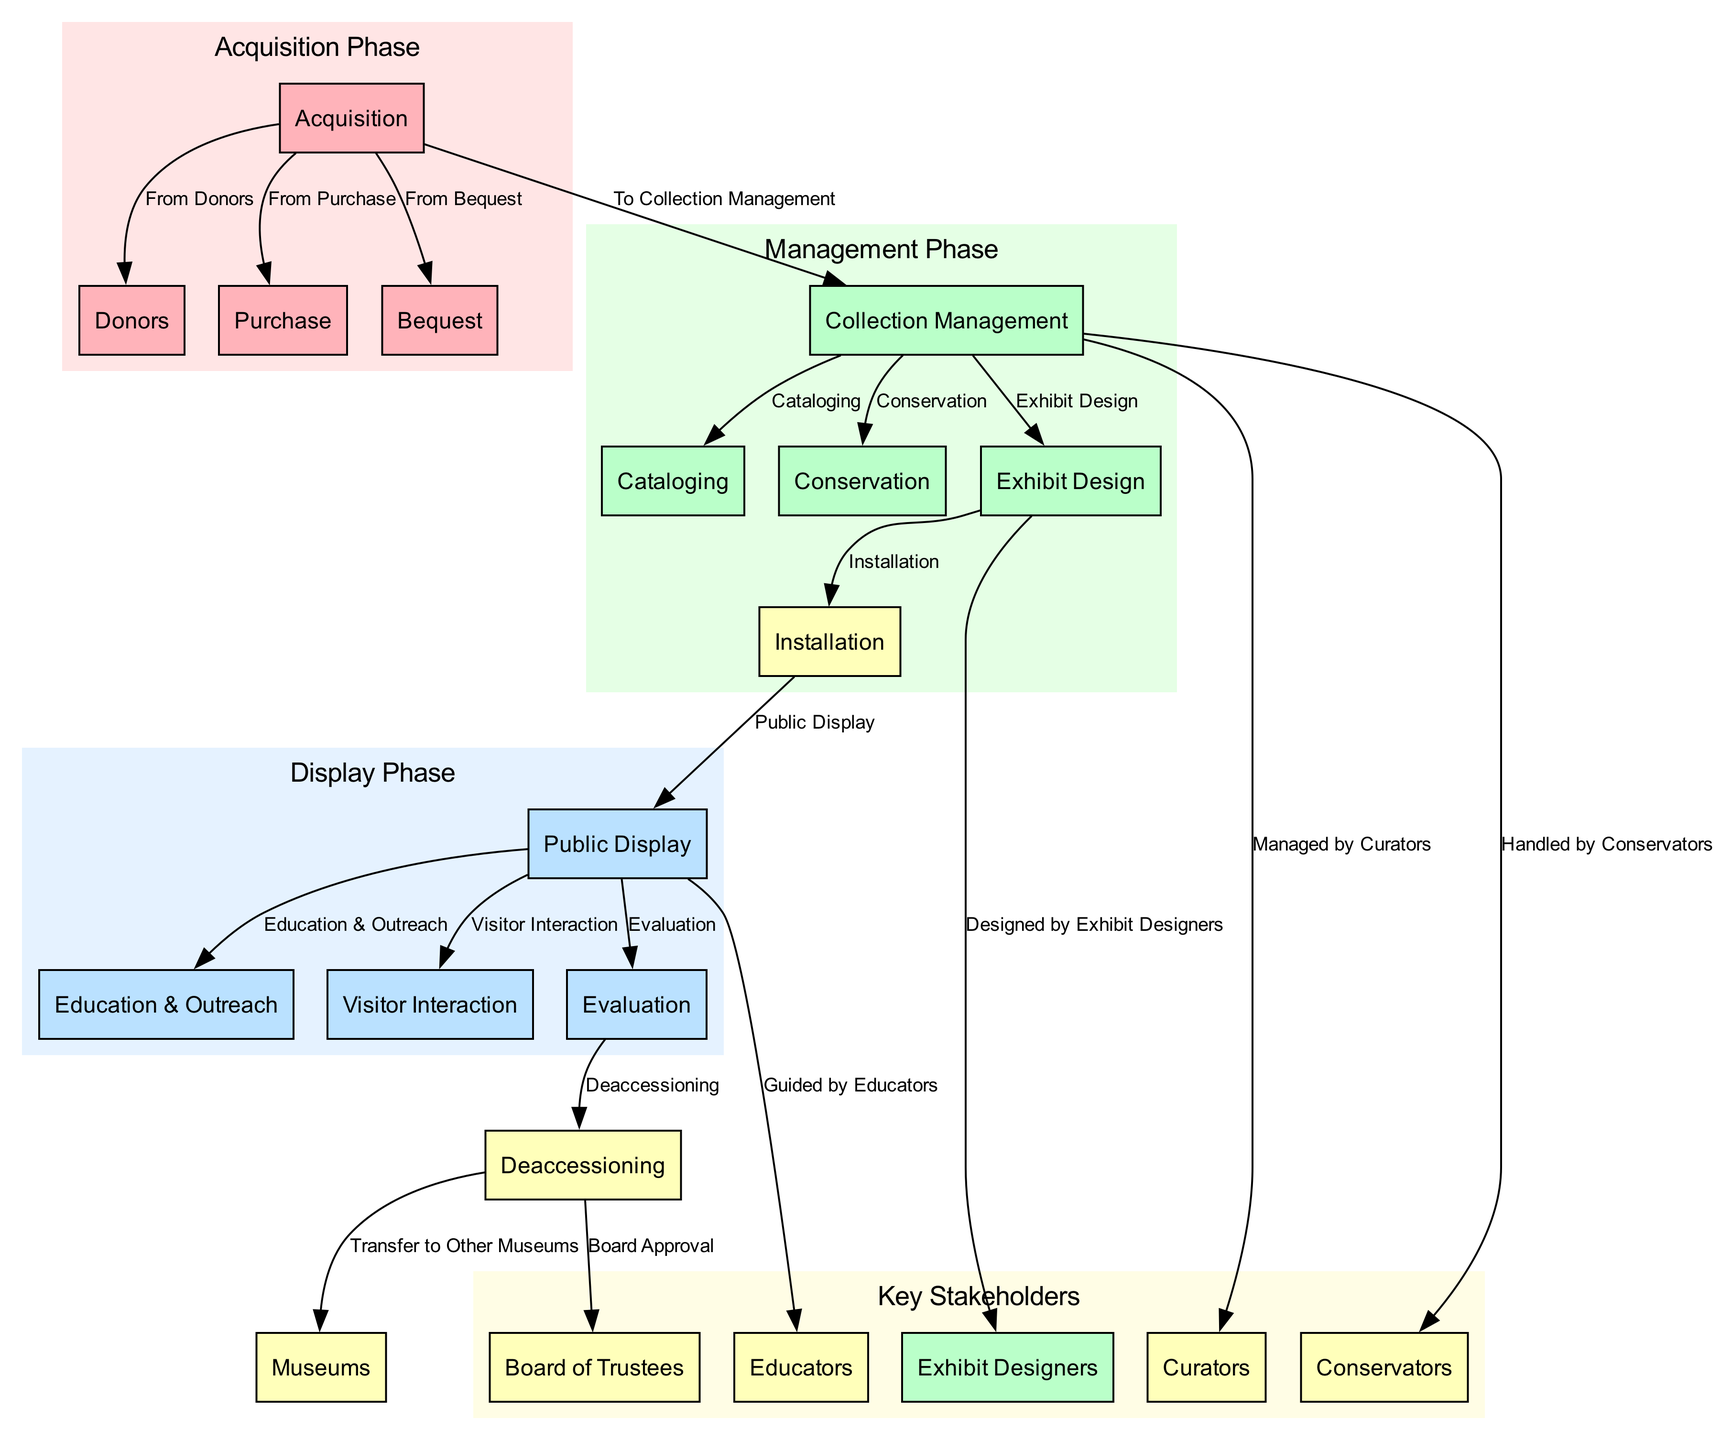What are the three sources of acquisition for museum exhibits? The diagram shows three sources of acquisition: Donors, Purchase, and Bequest. These are directly linked to the Acquisition node, indicating where exhibits can originate from.
Answer: Donors, Purchase, Bequest Which node follows the collection management phase? The collection management phase leads to several nodes, but specifically, the next phase is shown as Exhibit Design. It is reached through a direct relationship from the Collection Management node.
Answer: Exhibit Design How many key stakeholders are involved in the exhibit lifecycle according to the diagram? The diagram identifies five key stakeholders: Board of Trustees, Curators, Conservators, Educators, and Exhibit Designers. Counting these nodes provides the total.
Answer: Five What does the public display phase lead to? The public display phase connects to three nodes: Education & Outreach, Visitor Interaction, and Evaluation. Each of these nodes represents important functions following the public display of exhibits.
Answer: Education & Outreach, Visitor Interaction, Evaluation What is required before deaccessioning can occur according to the diagram? The diagram indicates that evaluation must occur before the process of deaccessioning begins. This sequence is necessary to assess exhibits' relevance or condition before removal.
Answer: Evaluation Who handles the conservation of the exhibits? The Conservators are responsible for handling the conservation of the exhibits, as indicated by the direct relationship flowing from the Collection Management node to the Conservators node.
Answer: Conservators How can exhibits be transferred according to the diagram? Exhibits can be transferred to other museums following deaccessioning, as shown by the edge leading from the Deaccessioning node to the Museums node. This indicates the route for redistributed exhibits.
Answer: Transfer to Other Museums Which process comes after installation in the exhibit lifecycle? The installation process leads directly to the public display of the exhibits, where they will be available for viewers to experience. This sequence shows the pathway from setup to audience engagement.
Answer: Public Display What is guided by educators during the public display phase? During the public display phase, Education & Outreach activities are guided by Educators, as indicated by the direct relationship shown in the diagram. This signifies the involvement of educators in facilitating public engagement.
Answer: Education & Outreach 